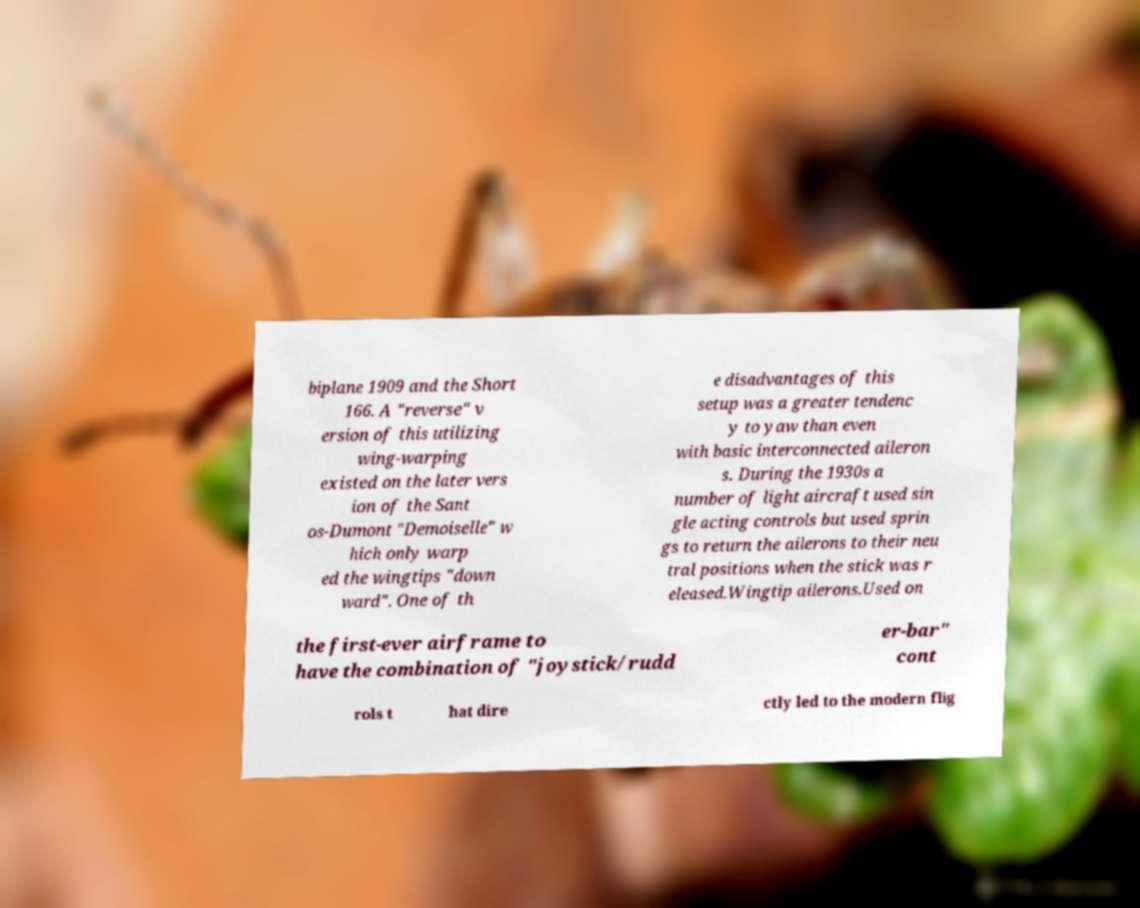Can you accurately transcribe the text from the provided image for me? biplane 1909 and the Short 166. A "reverse" v ersion of this utilizing wing-warping existed on the later vers ion of the Sant os-Dumont "Demoiselle" w hich only warp ed the wingtips "down ward". One of th e disadvantages of this setup was a greater tendenc y to yaw than even with basic interconnected aileron s. During the 1930s a number of light aircraft used sin gle acting controls but used sprin gs to return the ailerons to their neu tral positions when the stick was r eleased.Wingtip ailerons.Used on the first-ever airframe to have the combination of "joystick/rudd er-bar" cont rols t hat dire ctly led to the modern flig 